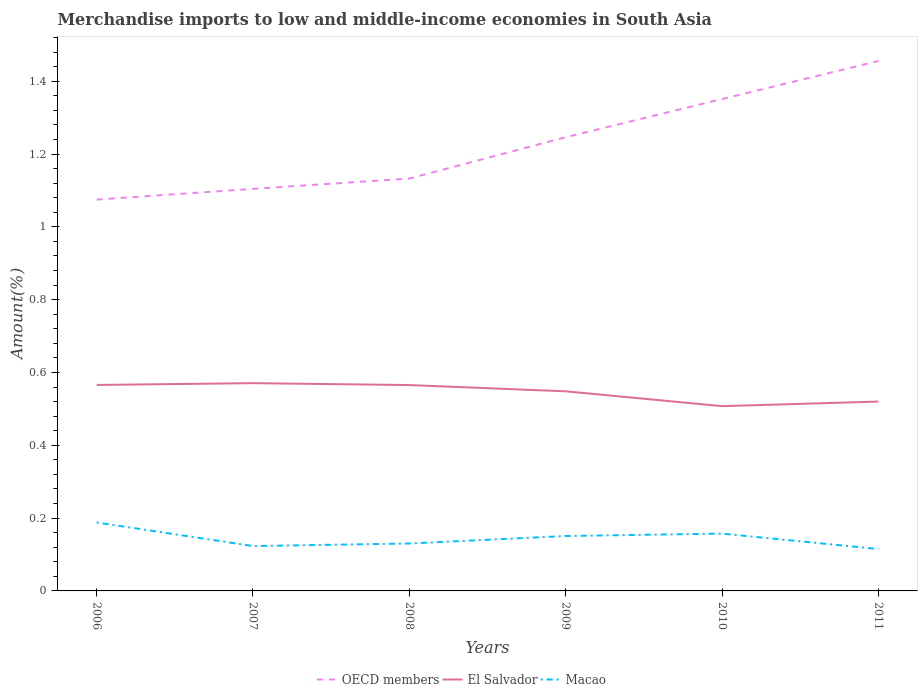Does the line corresponding to Macao intersect with the line corresponding to OECD members?
Your answer should be compact. No. Across all years, what is the maximum percentage of amount earned from merchandise imports in El Salvador?
Provide a short and direct response. 0.51. In which year was the percentage of amount earned from merchandise imports in OECD members maximum?
Offer a terse response. 2006. What is the total percentage of amount earned from merchandise imports in OECD members in the graph?
Offer a terse response. -0.11. What is the difference between the highest and the second highest percentage of amount earned from merchandise imports in OECD members?
Provide a short and direct response. 0.38. How many lines are there?
Provide a short and direct response. 3. How many years are there in the graph?
Provide a short and direct response. 6. What is the difference between two consecutive major ticks on the Y-axis?
Provide a succinct answer. 0.2. Does the graph contain any zero values?
Provide a succinct answer. No. Does the graph contain grids?
Make the answer very short. No. Where does the legend appear in the graph?
Make the answer very short. Bottom center. How many legend labels are there?
Your answer should be very brief. 3. How are the legend labels stacked?
Provide a short and direct response. Horizontal. What is the title of the graph?
Keep it short and to the point. Merchandise imports to low and middle-income economies in South Asia. Does "China" appear as one of the legend labels in the graph?
Provide a short and direct response. No. What is the label or title of the X-axis?
Give a very brief answer. Years. What is the label or title of the Y-axis?
Ensure brevity in your answer.  Amount(%). What is the Amount(%) of OECD members in 2006?
Your answer should be very brief. 1.07. What is the Amount(%) in El Salvador in 2006?
Make the answer very short. 0.57. What is the Amount(%) in Macao in 2006?
Keep it short and to the point. 0.19. What is the Amount(%) of OECD members in 2007?
Your answer should be compact. 1.1. What is the Amount(%) in El Salvador in 2007?
Make the answer very short. 0.57. What is the Amount(%) of Macao in 2007?
Ensure brevity in your answer.  0.12. What is the Amount(%) of OECD members in 2008?
Your answer should be compact. 1.13. What is the Amount(%) of El Salvador in 2008?
Make the answer very short. 0.57. What is the Amount(%) in Macao in 2008?
Offer a very short reply. 0.13. What is the Amount(%) of OECD members in 2009?
Offer a terse response. 1.25. What is the Amount(%) in El Salvador in 2009?
Offer a terse response. 0.55. What is the Amount(%) in Macao in 2009?
Give a very brief answer. 0.15. What is the Amount(%) of OECD members in 2010?
Your response must be concise. 1.35. What is the Amount(%) in El Salvador in 2010?
Keep it short and to the point. 0.51. What is the Amount(%) of Macao in 2010?
Ensure brevity in your answer.  0.16. What is the Amount(%) of OECD members in 2011?
Provide a succinct answer. 1.46. What is the Amount(%) in El Salvador in 2011?
Your answer should be compact. 0.52. What is the Amount(%) of Macao in 2011?
Your answer should be compact. 0.11. Across all years, what is the maximum Amount(%) in OECD members?
Your answer should be very brief. 1.46. Across all years, what is the maximum Amount(%) of El Salvador?
Your response must be concise. 0.57. Across all years, what is the maximum Amount(%) of Macao?
Your answer should be very brief. 0.19. Across all years, what is the minimum Amount(%) in OECD members?
Your answer should be very brief. 1.07. Across all years, what is the minimum Amount(%) of El Salvador?
Provide a short and direct response. 0.51. Across all years, what is the minimum Amount(%) in Macao?
Offer a terse response. 0.11. What is the total Amount(%) in OECD members in the graph?
Ensure brevity in your answer.  7.36. What is the total Amount(%) of El Salvador in the graph?
Your response must be concise. 3.28. What is the total Amount(%) of Macao in the graph?
Your response must be concise. 0.86. What is the difference between the Amount(%) in OECD members in 2006 and that in 2007?
Ensure brevity in your answer.  -0.03. What is the difference between the Amount(%) in El Salvador in 2006 and that in 2007?
Offer a terse response. -0.01. What is the difference between the Amount(%) in Macao in 2006 and that in 2007?
Provide a succinct answer. 0.06. What is the difference between the Amount(%) in OECD members in 2006 and that in 2008?
Make the answer very short. -0.06. What is the difference between the Amount(%) in Macao in 2006 and that in 2008?
Make the answer very short. 0.06. What is the difference between the Amount(%) in OECD members in 2006 and that in 2009?
Keep it short and to the point. -0.17. What is the difference between the Amount(%) in El Salvador in 2006 and that in 2009?
Offer a terse response. 0.02. What is the difference between the Amount(%) of Macao in 2006 and that in 2009?
Offer a very short reply. 0.04. What is the difference between the Amount(%) in OECD members in 2006 and that in 2010?
Give a very brief answer. -0.28. What is the difference between the Amount(%) in El Salvador in 2006 and that in 2010?
Offer a terse response. 0.06. What is the difference between the Amount(%) in Macao in 2006 and that in 2010?
Your answer should be very brief. 0.03. What is the difference between the Amount(%) of OECD members in 2006 and that in 2011?
Your response must be concise. -0.38. What is the difference between the Amount(%) in El Salvador in 2006 and that in 2011?
Give a very brief answer. 0.05. What is the difference between the Amount(%) in Macao in 2006 and that in 2011?
Give a very brief answer. 0.07. What is the difference between the Amount(%) in OECD members in 2007 and that in 2008?
Ensure brevity in your answer.  -0.03. What is the difference between the Amount(%) in El Salvador in 2007 and that in 2008?
Offer a very short reply. 0.01. What is the difference between the Amount(%) of Macao in 2007 and that in 2008?
Ensure brevity in your answer.  -0.01. What is the difference between the Amount(%) of OECD members in 2007 and that in 2009?
Your answer should be compact. -0.14. What is the difference between the Amount(%) in El Salvador in 2007 and that in 2009?
Provide a succinct answer. 0.02. What is the difference between the Amount(%) in Macao in 2007 and that in 2009?
Provide a short and direct response. -0.03. What is the difference between the Amount(%) in OECD members in 2007 and that in 2010?
Offer a very short reply. -0.25. What is the difference between the Amount(%) of El Salvador in 2007 and that in 2010?
Provide a succinct answer. 0.06. What is the difference between the Amount(%) in Macao in 2007 and that in 2010?
Provide a succinct answer. -0.03. What is the difference between the Amount(%) in OECD members in 2007 and that in 2011?
Give a very brief answer. -0.35. What is the difference between the Amount(%) of El Salvador in 2007 and that in 2011?
Give a very brief answer. 0.05. What is the difference between the Amount(%) in Macao in 2007 and that in 2011?
Your response must be concise. 0.01. What is the difference between the Amount(%) of OECD members in 2008 and that in 2009?
Offer a very short reply. -0.11. What is the difference between the Amount(%) in El Salvador in 2008 and that in 2009?
Provide a succinct answer. 0.02. What is the difference between the Amount(%) in Macao in 2008 and that in 2009?
Give a very brief answer. -0.02. What is the difference between the Amount(%) of OECD members in 2008 and that in 2010?
Your answer should be very brief. -0.22. What is the difference between the Amount(%) in El Salvador in 2008 and that in 2010?
Offer a terse response. 0.06. What is the difference between the Amount(%) in Macao in 2008 and that in 2010?
Your response must be concise. -0.03. What is the difference between the Amount(%) of OECD members in 2008 and that in 2011?
Make the answer very short. -0.32. What is the difference between the Amount(%) in El Salvador in 2008 and that in 2011?
Provide a succinct answer. 0.05. What is the difference between the Amount(%) of Macao in 2008 and that in 2011?
Give a very brief answer. 0.02. What is the difference between the Amount(%) in OECD members in 2009 and that in 2010?
Your answer should be very brief. -0.1. What is the difference between the Amount(%) in El Salvador in 2009 and that in 2010?
Keep it short and to the point. 0.04. What is the difference between the Amount(%) in Macao in 2009 and that in 2010?
Your response must be concise. -0.01. What is the difference between the Amount(%) in OECD members in 2009 and that in 2011?
Your answer should be compact. -0.21. What is the difference between the Amount(%) in El Salvador in 2009 and that in 2011?
Your response must be concise. 0.03. What is the difference between the Amount(%) of Macao in 2009 and that in 2011?
Your response must be concise. 0.04. What is the difference between the Amount(%) in OECD members in 2010 and that in 2011?
Your response must be concise. -0.1. What is the difference between the Amount(%) in El Salvador in 2010 and that in 2011?
Make the answer very short. -0.01. What is the difference between the Amount(%) in Macao in 2010 and that in 2011?
Your response must be concise. 0.04. What is the difference between the Amount(%) in OECD members in 2006 and the Amount(%) in El Salvador in 2007?
Offer a very short reply. 0.5. What is the difference between the Amount(%) of OECD members in 2006 and the Amount(%) of Macao in 2007?
Give a very brief answer. 0.95. What is the difference between the Amount(%) of El Salvador in 2006 and the Amount(%) of Macao in 2007?
Your response must be concise. 0.44. What is the difference between the Amount(%) in OECD members in 2006 and the Amount(%) in El Salvador in 2008?
Keep it short and to the point. 0.51. What is the difference between the Amount(%) of OECD members in 2006 and the Amount(%) of Macao in 2008?
Give a very brief answer. 0.94. What is the difference between the Amount(%) of El Salvador in 2006 and the Amount(%) of Macao in 2008?
Give a very brief answer. 0.44. What is the difference between the Amount(%) in OECD members in 2006 and the Amount(%) in El Salvador in 2009?
Provide a short and direct response. 0.53. What is the difference between the Amount(%) in OECD members in 2006 and the Amount(%) in Macao in 2009?
Make the answer very short. 0.92. What is the difference between the Amount(%) of El Salvador in 2006 and the Amount(%) of Macao in 2009?
Offer a very short reply. 0.41. What is the difference between the Amount(%) in OECD members in 2006 and the Amount(%) in El Salvador in 2010?
Your answer should be very brief. 0.57. What is the difference between the Amount(%) in OECD members in 2006 and the Amount(%) in Macao in 2010?
Provide a succinct answer. 0.92. What is the difference between the Amount(%) of El Salvador in 2006 and the Amount(%) of Macao in 2010?
Offer a very short reply. 0.41. What is the difference between the Amount(%) in OECD members in 2006 and the Amount(%) in El Salvador in 2011?
Make the answer very short. 0.55. What is the difference between the Amount(%) in OECD members in 2006 and the Amount(%) in Macao in 2011?
Give a very brief answer. 0.96. What is the difference between the Amount(%) in El Salvador in 2006 and the Amount(%) in Macao in 2011?
Your answer should be very brief. 0.45. What is the difference between the Amount(%) in OECD members in 2007 and the Amount(%) in El Salvador in 2008?
Provide a short and direct response. 0.54. What is the difference between the Amount(%) in OECD members in 2007 and the Amount(%) in Macao in 2008?
Keep it short and to the point. 0.97. What is the difference between the Amount(%) of El Salvador in 2007 and the Amount(%) of Macao in 2008?
Offer a very short reply. 0.44. What is the difference between the Amount(%) in OECD members in 2007 and the Amount(%) in El Salvador in 2009?
Your response must be concise. 0.56. What is the difference between the Amount(%) in OECD members in 2007 and the Amount(%) in Macao in 2009?
Keep it short and to the point. 0.95. What is the difference between the Amount(%) in El Salvador in 2007 and the Amount(%) in Macao in 2009?
Your answer should be compact. 0.42. What is the difference between the Amount(%) in OECD members in 2007 and the Amount(%) in El Salvador in 2010?
Provide a succinct answer. 0.6. What is the difference between the Amount(%) in OECD members in 2007 and the Amount(%) in Macao in 2010?
Give a very brief answer. 0.95. What is the difference between the Amount(%) in El Salvador in 2007 and the Amount(%) in Macao in 2010?
Provide a short and direct response. 0.41. What is the difference between the Amount(%) in OECD members in 2007 and the Amount(%) in El Salvador in 2011?
Ensure brevity in your answer.  0.58. What is the difference between the Amount(%) in OECD members in 2007 and the Amount(%) in Macao in 2011?
Provide a succinct answer. 0.99. What is the difference between the Amount(%) in El Salvador in 2007 and the Amount(%) in Macao in 2011?
Offer a very short reply. 0.46. What is the difference between the Amount(%) in OECD members in 2008 and the Amount(%) in El Salvador in 2009?
Offer a very short reply. 0.58. What is the difference between the Amount(%) of OECD members in 2008 and the Amount(%) of Macao in 2009?
Ensure brevity in your answer.  0.98. What is the difference between the Amount(%) in El Salvador in 2008 and the Amount(%) in Macao in 2009?
Your answer should be compact. 0.41. What is the difference between the Amount(%) in OECD members in 2008 and the Amount(%) in El Salvador in 2010?
Ensure brevity in your answer.  0.63. What is the difference between the Amount(%) in OECD members in 2008 and the Amount(%) in Macao in 2010?
Offer a terse response. 0.98. What is the difference between the Amount(%) in El Salvador in 2008 and the Amount(%) in Macao in 2010?
Provide a succinct answer. 0.41. What is the difference between the Amount(%) of OECD members in 2008 and the Amount(%) of El Salvador in 2011?
Make the answer very short. 0.61. What is the difference between the Amount(%) in OECD members in 2008 and the Amount(%) in Macao in 2011?
Keep it short and to the point. 1.02. What is the difference between the Amount(%) in El Salvador in 2008 and the Amount(%) in Macao in 2011?
Your answer should be very brief. 0.45. What is the difference between the Amount(%) of OECD members in 2009 and the Amount(%) of El Salvador in 2010?
Ensure brevity in your answer.  0.74. What is the difference between the Amount(%) of OECD members in 2009 and the Amount(%) of Macao in 2010?
Offer a terse response. 1.09. What is the difference between the Amount(%) in El Salvador in 2009 and the Amount(%) in Macao in 2010?
Keep it short and to the point. 0.39. What is the difference between the Amount(%) in OECD members in 2009 and the Amount(%) in El Salvador in 2011?
Your response must be concise. 0.73. What is the difference between the Amount(%) of OECD members in 2009 and the Amount(%) of Macao in 2011?
Keep it short and to the point. 1.13. What is the difference between the Amount(%) of El Salvador in 2009 and the Amount(%) of Macao in 2011?
Offer a very short reply. 0.43. What is the difference between the Amount(%) in OECD members in 2010 and the Amount(%) in El Salvador in 2011?
Ensure brevity in your answer.  0.83. What is the difference between the Amount(%) in OECD members in 2010 and the Amount(%) in Macao in 2011?
Provide a short and direct response. 1.24. What is the difference between the Amount(%) of El Salvador in 2010 and the Amount(%) of Macao in 2011?
Make the answer very short. 0.39. What is the average Amount(%) in OECD members per year?
Ensure brevity in your answer.  1.23. What is the average Amount(%) in El Salvador per year?
Provide a short and direct response. 0.55. What is the average Amount(%) in Macao per year?
Your answer should be very brief. 0.14. In the year 2006, what is the difference between the Amount(%) of OECD members and Amount(%) of El Salvador?
Your answer should be very brief. 0.51. In the year 2006, what is the difference between the Amount(%) in OECD members and Amount(%) in Macao?
Give a very brief answer. 0.89. In the year 2006, what is the difference between the Amount(%) in El Salvador and Amount(%) in Macao?
Keep it short and to the point. 0.38. In the year 2007, what is the difference between the Amount(%) of OECD members and Amount(%) of El Salvador?
Your answer should be very brief. 0.53. In the year 2007, what is the difference between the Amount(%) in OECD members and Amount(%) in Macao?
Offer a very short reply. 0.98. In the year 2007, what is the difference between the Amount(%) of El Salvador and Amount(%) of Macao?
Keep it short and to the point. 0.45. In the year 2008, what is the difference between the Amount(%) of OECD members and Amount(%) of El Salvador?
Ensure brevity in your answer.  0.57. In the year 2008, what is the difference between the Amount(%) of El Salvador and Amount(%) of Macao?
Your answer should be compact. 0.44. In the year 2009, what is the difference between the Amount(%) in OECD members and Amount(%) in El Salvador?
Provide a short and direct response. 0.7. In the year 2009, what is the difference between the Amount(%) in OECD members and Amount(%) in Macao?
Your answer should be very brief. 1.1. In the year 2009, what is the difference between the Amount(%) in El Salvador and Amount(%) in Macao?
Your answer should be compact. 0.4. In the year 2010, what is the difference between the Amount(%) of OECD members and Amount(%) of El Salvador?
Offer a terse response. 0.84. In the year 2010, what is the difference between the Amount(%) in OECD members and Amount(%) in Macao?
Offer a terse response. 1.19. In the year 2011, what is the difference between the Amount(%) of OECD members and Amount(%) of El Salvador?
Your answer should be very brief. 0.94. In the year 2011, what is the difference between the Amount(%) in OECD members and Amount(%) in Macao?
Offer a terse response. 1.34. In the year 2011, what is the difference between the Amount(%) of El Salvador and Amount(%) of Macao?
Offer a very short reply. 0.41. What is the ratio of the Amount(%) in OECD members in 2006 to that in 2007?
Offer a terse response. 0.97. What is the ratio of the Amount(%) of El Salvador in 2006 to that in 2007?
Offer a terse response. 0.99. What is the ratio of the Amount(%) of Macao in 2006 to that in 2007?
Offer a terse response. 1.53. What is the ratio of the Amount(%) in OECD members in 2006 to that in 2008?
Provide a short and direct response. 0.95. What is the ratio of the Amount(%) of El Salvador in 2006 to that in 2008?
Offer a very short reply. 1. What is the ratio of the Amount(%) in Macao in 2006 to that in 2008?
Your response must be concise. 1.44. What is the ratio of the Amount(%) of OECD members in 2006 to that in 2009?
Your answer should be compact. 0.86. What is the ratio of the Amount(%) in El Salvador in 2006 to that in 2009?
Provide a succinct answer. 1.03. What is the ratio of the Amount(%) in Macao in 2006 to that in 2009?
Your answer should be compact. 1.25. What is the ratio of the Amount(%) of OECD members in 2006 to that in 2010?
Provide a succinct answer. 0.8. What is the ratio of the Amount(%) of El Salvador in 2006 to that in 2010?
Your answer should be very brief. 1.11. What is the ratio of the Amount(%) of Macao in 2006 to that in 2010?
Your answer should be compact. 1.19. What is the ratio of the Amount(%) in OECD members in 2006 to that in 2011?
Give a very brief answer. 0.74. What is the ratio of the Amount(%) in El Salvador in 2006 to that in 2011?
Ensure brevity in your answer.  1.09. What is the ratio of the Amount(%) in Macao in 2006 to that in 2011?
Offer a very short reply. 1.64. What is the ratio of the Amount(%) in OECD members in 2007 to that in 2008?
Make the answer very short. 0.97. What is the ratio of the Amount(%) of El Salvador in 2007 to that in 2008?
Keep it short and to the point. 1.01. What is the ratio of the Amount(%) in Macao in 2007 to that in 2008?
Keep it short and to the point. 0.95. What is the ratio of the Amount(%) of OECD members in 2007 to that in 2009?
Give a very brief answer. 0.89. What is the ratio of the Amount(%) in El Salvador in 2007 to that in 2009?
Offer a terse response. 1.04. What is the ratio of the Amount(%) of Macao in 2007 to that in 2009?
Make the answer very short. 0.82. What is the ratio of the Amount(%) in OECD members in 2007 to that in 2010?
Provide a short and direct response. 0.82. What is the ratio of the Amount(%) of El Salvador in 2007 to that in 2010?
Provide a short and direct response. 1.12. What is the ratio of the Amount(%) of Macao in 2007 to that in 2010?
Keep it short and to the point. 0.78. What is the ratio of the Amount(%) in OECD members in 2007 to that in 2011?
Your answer should be compact. 0.76. What is the ratio of the Amount(%) of El Salvador in 2007 to that in 2011?
Offer a very short reply. 1.1. What is the ratio of the Amount(%) of Macao in 2007 to that in 2011?
Provide a short and direct response. 1.07. What is the ratio of the Amount(%) of OECD members in 2008 to that in 2009?
Make the answer very short. 0.91. What is the ratio of the Amount(%) of El Salvador in 2008 to that in 2009?
Ensure brevity in your answer.  1.03. What is the ratio of the Amount(%) of Macao in 2008 to that in 2009?
Your response must be concise. 0.86. What is the ratio of the Amount(%) of OECD members in 2008 to that in 2010?
Give a very brief answer. 0.84. What is the ratio of the Amount(%) in El Salvador in 2008 to that in 2010?
Offer a terse response. 1.11. What is the ratio of the Amount(%) of Macao in 2008 to that in 2010?
Keep it short and to the point. 0.83. What is the ratio of the Amount(%) of OECD members in 2008 to that in 2011?
Provide a succinct answer. 0.78. What is the ratio of the Amount(%) of El Salvador in 2008 to that in 2011?
Keep it short and to the point. 1.09. What is the ratio of the Amount(%) in Macao in 2008 to that in 2011?
Your answer should be very brief. 1.13. What is the ratio of the Amount(%) in OECD members in 2009 to that in 2010?
Your response must be concise. 0.92. What is the ratio of the Amount(%) in El Salvador in 2009 to that in 2010?
Provide a short and direct response. 1.08. What is the ratio of the Amount(%) of Macao in 2009 to that in 2010?
Your response must be concise. 0.96. What is the ratio of the Amount(%) of OECD members in 2009 to that in 2011?
Your answer should be compact. 0.86. What is the ratio of the Amount(%) in El Salvador in 2009 to that in 2011?
Give a very brief answer. 1.05. What is the ratio of the Amount(%) in Macao in 2009 to that in 2011?
Give a very brief answer. 1.31. What is the ratio of the Amount(%) of OECD members in 2010 to that in 2011?
Give a very brief answer. 0.93. What is the ratio of the Amount(%) of El Salvador in 2010 to that in 2011?
Make the answer very short. 0.98. What is the ratio of the Amount(%) in Macao in 2010 to that in 2011?
Your answer should be compact. 1.37. What is the difference between the highest and the second highest Amount(%) in OECD members?
Offer a very short reply. 0.1. What is the difference between the highest and the second highest Amount(%) in El Salvador?
Provide a succinct answer. 0.01. What is the difference between the highest and the second highest Amount(%) in Macao?
Your answer should be very brief. 0.03. What is the difference between the highest and the lowest Amount(%) of OECD members?
Ensure brevity in your answer.  0.38. What is the difference between the highest and the lowest Amount(%) of El Salvador?
Make the answer very short. 0.06. What is the difference between the highest and the lowest Amount(%) in Macao?
Ensure brevity in your answer.  0.07. 